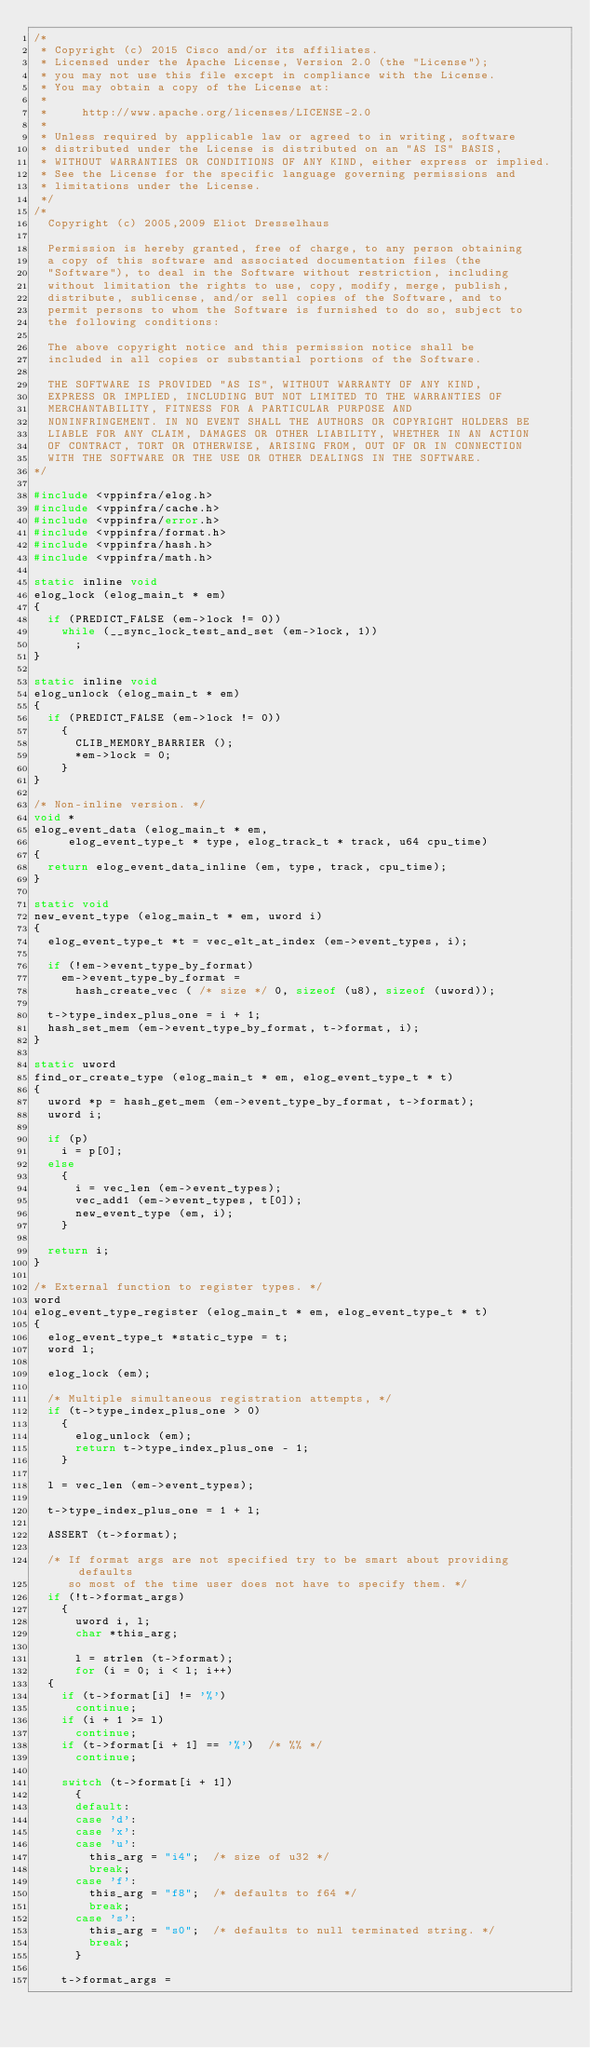<code> <loc_0><loc_0><loc_500><loc_500><_C_>/*
 * Copyright (c) 2015 Cisco and/or its affiliates.
 * Licensed under the Apache License, Version 2.0 (the "License");
 * you may not use this file except in compliance with the License.
 * You may obtain a copy of the License at:
 *
 *     http://www.apache.org/licenses/LICENSE-2.0
 *
 * Unless required by applicable law or agreed to in writing, software
 * distributed under the License is distributed on an "AS IS" BASIS,
 * WITHOUT WARRANTIES OR CONDITIONS OF ANY KIND, either express or implied.
 * See the License for the specific language governing permissions and
 * limitations under the License.
 */
/*
  Copyright (c) 2005,2009 Eliot Dresselhaus

  Permission is hereby granted, free of charge, to any person obtaining
  a copy of this software and associated documentation files (the
  "Software"), to deal in the Software without restriction, including
  without limitation the rights to use, copy, modify, merge, publish,
  distribute, sublicense, and/or sell copies of the Software, and to
  permit persons to whom the Software is furnished to do so, subject to
  the following conditions:

  The above copyright notice and this permission notice shall be
  included in all copies or substantial portions of the Software.

  THE SOFTWARE IS PROVIDED "AS IS", WITHOUT WARRANTY OF ANY KIND,
  EXPRESS OR IMPLIED, INCLUDING BUT NOT LIMITED TO THE WARRANTIES OF
  MERCHANTABILITY, FITNESS FOR A PARTICULAR PURPOSE AND
  NONINFRINGEMENT. IN NO EVENT SHALL THE AUTHORS OR COPYRIGHT HOLDERS BE
  LIABLE FOR ANY CLAIM, DAMAGES OR OTHER LIABILITY, WHETHER IN AN ACTION
  OF CONTRACT, TORT OR OTHERWISE, ARISING FROM, OUT OF OR IN CONNECTION
  WITH THE SOFTWARE OR THE USE OR OTHER DEALINGS IN THE SOFTWARE.
*/

#include <vppinfra/elog.h>
#include <vppinfra/cache.h>
#include <vppinfra/error.h>
#include <vppinfra/format.h>
#include <vppinfra/hash.h>
#include <vppinfra/math.h>

static inline void
elog_lock (elog_main_t * em)
{
  if (PREDICT_FALSE (em->lock != 0))
    while (__sync_lock_test_and_set (em->lock, 1))
      ;
}

static inline void
elog_unlock (elog_main_t * em)
{
  if (PREDICT_FALSE (em->lock != 0))
    {
      CLIB_MEMORY_BARRIER ();
      *em->lock = 0;
    }
}

/* Non-inline version. */
void *
elog_event_data (elog_main_t * em,
		 elog_event_type_t * type, elog_track_t * track, u64 cpu_time)
{
  return elog_event_data_inline (em, type, track, cpu_time);
}

static void
new_event_type (elog_main_t * em, uword i)
{
  elog_event_type_t *t = vec_elt_at_index (em->event_types, i);

  if (!em->event_type_by_format)
    em->event_type_by_format =
      hash_create_vec ( /* size */ 0, sizeof (u8), sizeof (uword));

  t->type_index_plus_one = i + 1;
  hash_set_mem (em->event_type_by_format, t->format, i);
}

static uword
find_or_create_type (elog_main_t * em, elog_event_type_t * t)
{
  uword *p = hash_get_mem (em->event_type_by_format, t->format);
  uword i;

  if (p)
    i = p[0];
  else
    {
      i = vec_len (em->event_types);
      vec_add1 (em->event_types, t[0]);
      new_event_type (em, i);
    }

  return i;
}

/* External function to register types. */
word
elog_event_type_register (elog_main_t * em, elog_event_type_t * t)
{
  elog_event_type_t *static_type = t;
  word l;

  elog_lock (em);

  /* Multiple simultaneous registration attempts, */
  if (t->type_index_plus_one > 0)
    {
      elog_unlock (em);
      return t->type_index_plus_one - 1;
    }

  l = vec_len (em->event_types);

  t->type_index_plus_one = 1 + l;

  ASSERT (t->format);

  /* If format args are not specified try to be smart about providing defaults
     so most of the time user does not have to specify them. */
  if (!t->format_args)
    {
      uword i, l;
      char *this_arg;

      l = strlen (t->format);
      for (i = 0; i < l; i++)
	{
	  if (t->format[i] != '%')
	    continue;
	  if (i + 1 >= l)
	    continue;
	  if (t->format[i + 1] == '%')	/* %% */
	    continue;

	  switch (t->format[i + 1])
	    {
	    default:
	    case 'd':
	    case 'x':
	    case 'u':
	      this_arg = "i4";	/* size of u32 */
	      break;
	    case 'f':
	      this_arg = "f8";	/* defaults to f64 */
	      break;
	    case 's':
	      this_arg = "s0";	/* defaults to null terminated string. */
	      break;
	    }

	  t->format_args =</code> 